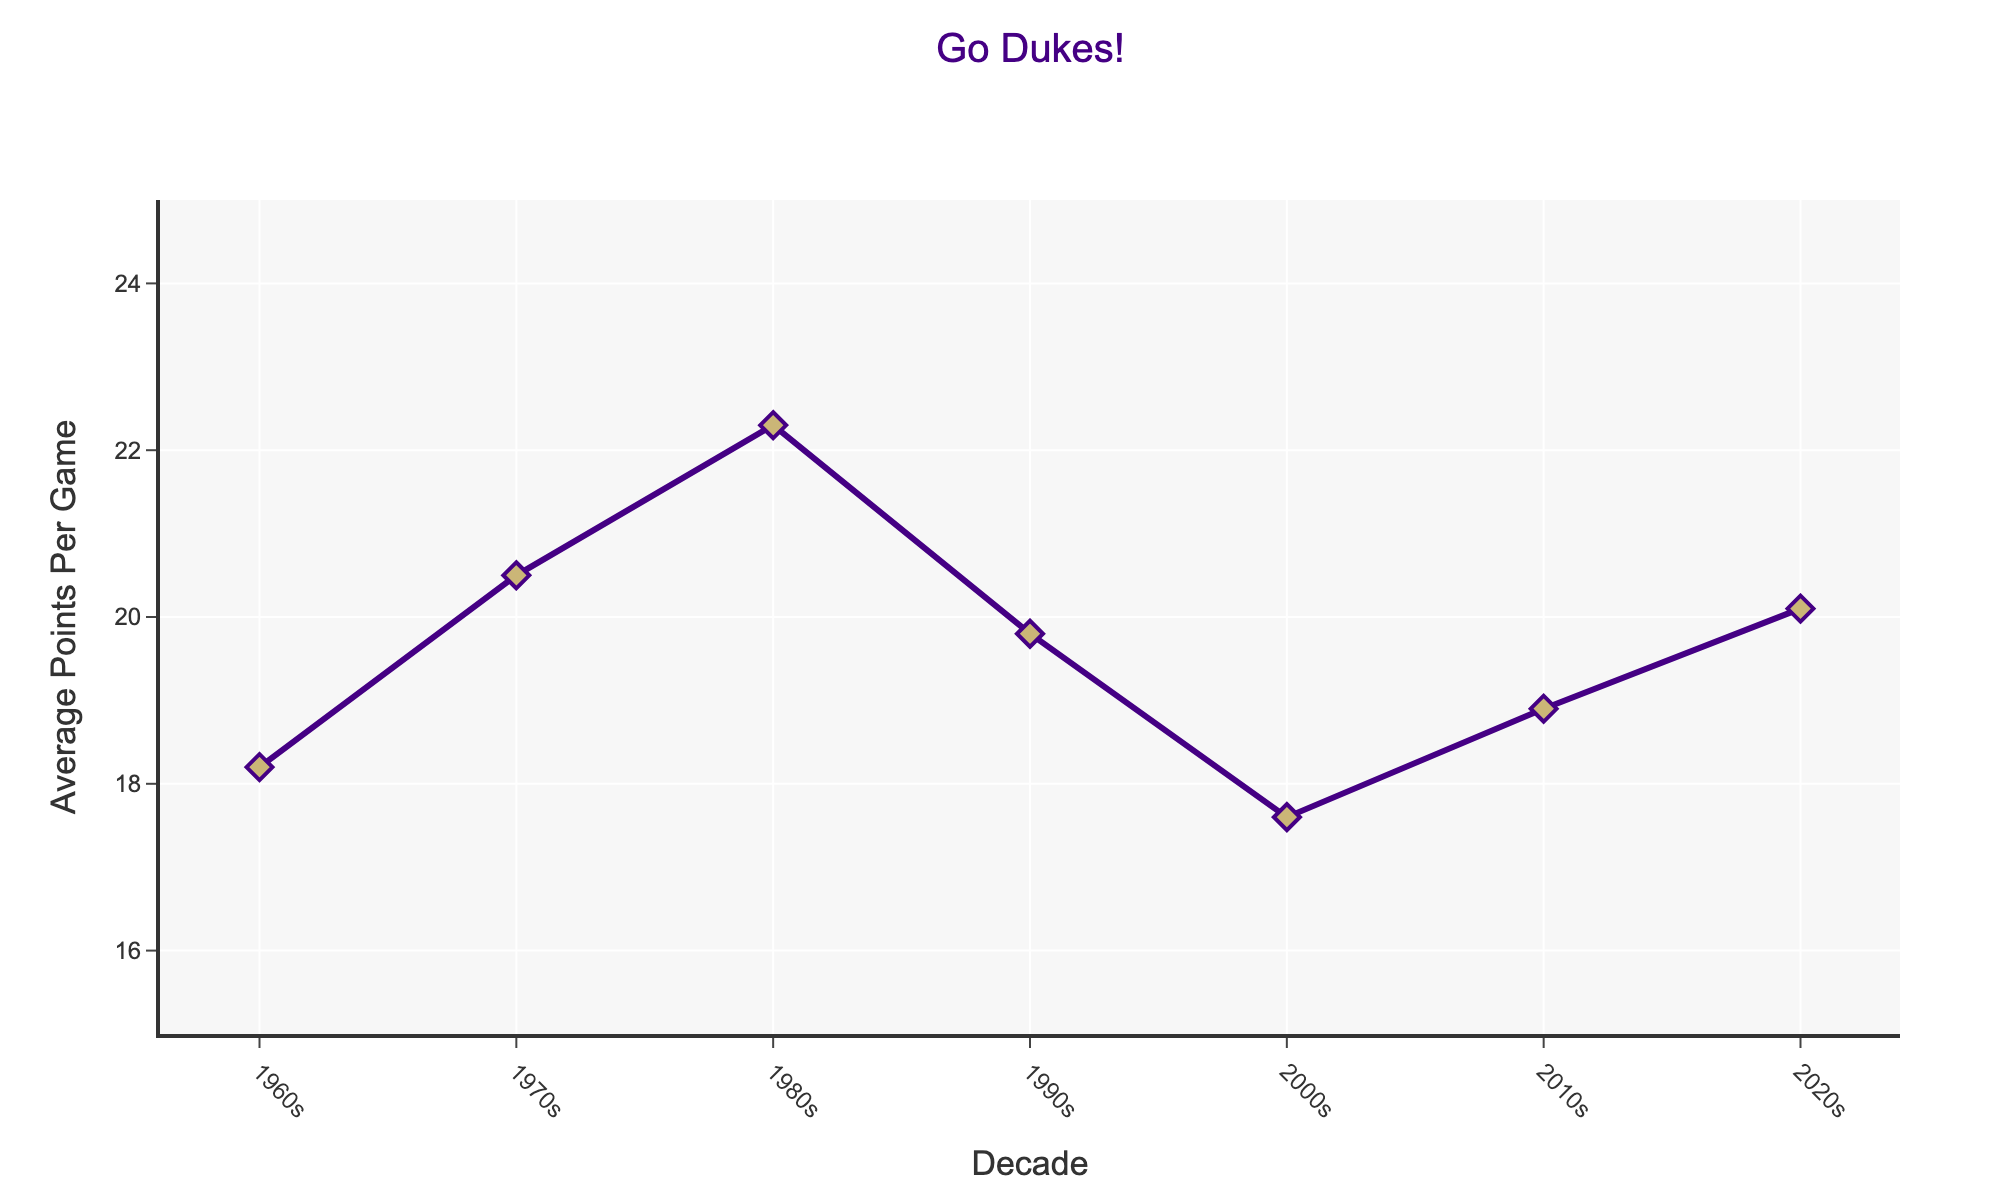Which decade had the highest average points per game for JMU's top scorers? By examining the figure, the 1980s show the highest point on the graph.
Answer: 1980s Which decade had the lowest average points per game for JMU's top scorers? The 2000s had the lowest point on the graph.
Answer: 2000s Is there a decade where the average points per game were between 19 and 20? By examining the graph, the 1990s' average points per game fall within this range.
Answer: 1990s How much higher was the average points per game in the 1980s compared to the 2000s? The 1980s had an average of 22.3 points, while the 2000s had 17.6 points. The difference is 22.3 - 17.6 = 4.7 points.
Answer: 4.7 points What is the trend in the average points per game from the 1960s to the 1980s? From the 1960s to the 1980s, the average points per game consistently increased.
Answer: Increasing How did the average points per game change from the 2010s to the 2020s? The average increased from 18.9 points in the 2010s to 20.1 points in the 2020s.
Answer: Increased Which two decades have the closest average points per game? The 1960s (18.2) and the 2010s (18.9) have the closest averages. The difference is 18.9 - 18.2 = 0.7 points.
Answer: 1960s and 2010s What's the difference in average points per game between the highest and lowest decades? The highest average is from the 1980s at 22.3 points, and the lowest is from the 2000s at 17.6 points. The difference is 22.3 - 17.6 = 4.7 points.
Answer: 4.7 points Is there a significant jump in average points per game between two consecutive decades? If so, which ones? The 1970s to the 1980s show the most significant jump from 20.5 to 22.3, a difference of 1.8 points.
Answer: 1970s to 1980s Compare the average points per game of the 1960s and 2010s. Are they more similar or different? The average points per game in the 1960s and 2010s are 18.2 and 18.9, respectively. The difference is 0.7 points, which is relatively small.
Answer: More similar 